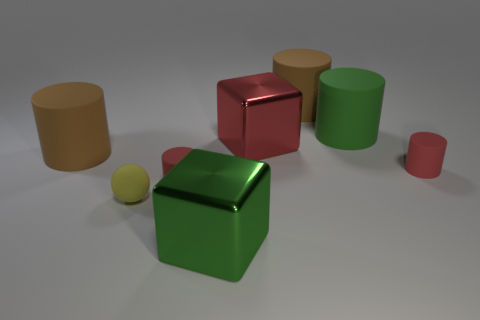Subtract all green cylinders. How many cylinders are left? 4 Add 2 red metal blocks. How many objects exist? 10 Subtract all brown cylinders. How many cylinders are left? 3 Add 8 cubes. How many cubes are left? 10 Add 7 big blue shiny things. How many big blue shiny things exist? 7 Subtract 1 red cylinders. How many objects are left? 7 Subtract all spheres. How many objects are left? 7 Subtract 4 cylinders. How many cylinders are left? 1 Subtract all red cubes. Subtract all cyan cylinders. How many cubes are left? 1 Subtract all gray balls. How many purple blocks are left? 0 